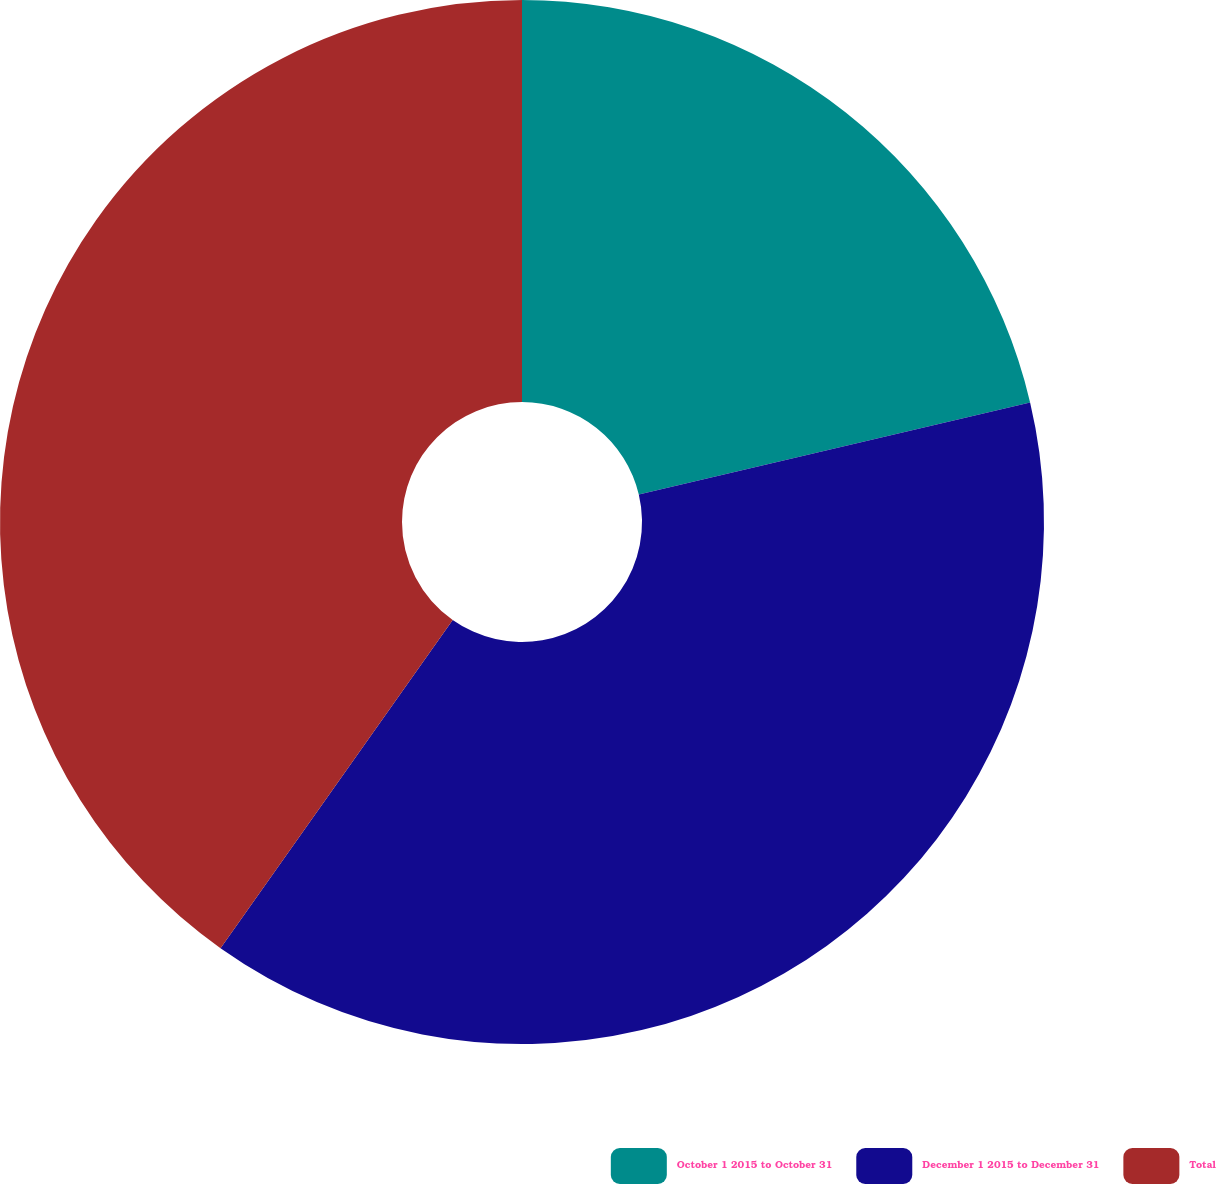<chart> <loc_0><loc_0><loc_500><loc_500><pie_chart><fcel>October 1 2015 to October 31<fcel>December 1 2015 to December 31<fcel>Total<nl><fcel>21.32%<fcel>38.48%<fcel>40.2%<nl></chart> 